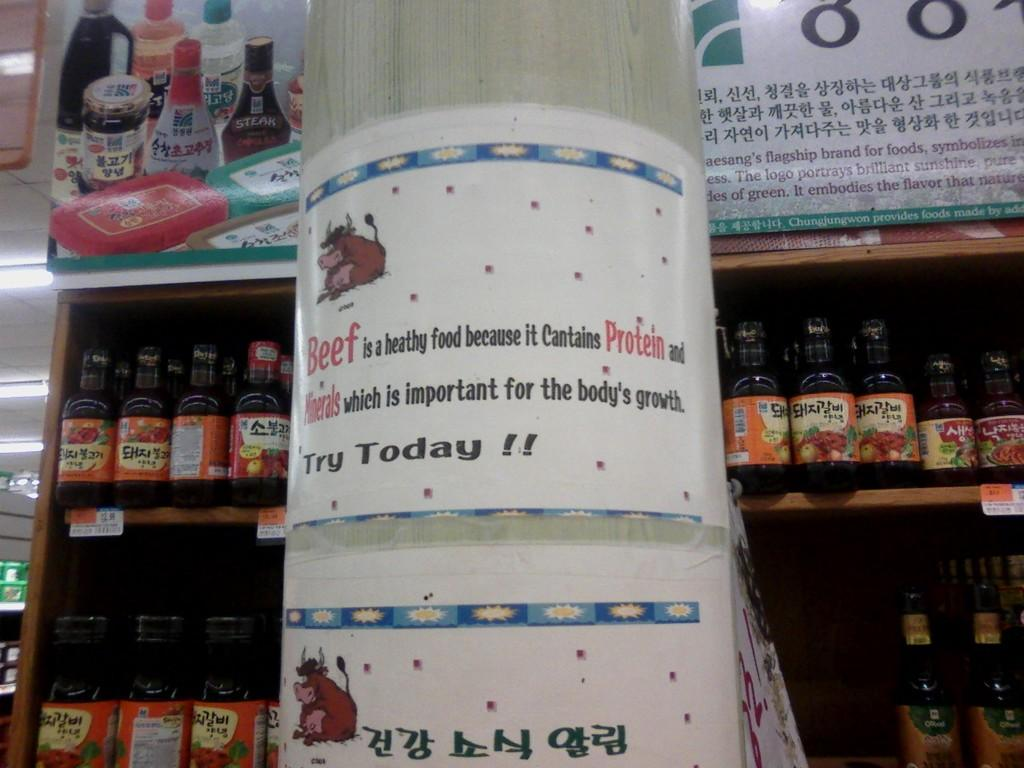Provide a one-sentence caption for the provided image. Beef contains protein and minerals which is important for the body to grow. 